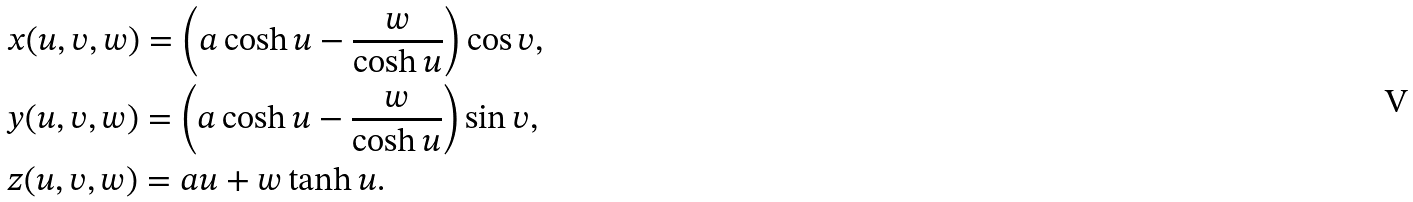Convert formula to latex. <formula><loc_0><loc_0><loc_500><loc_500>& x ( u , v , w ) = \left ( a \cosh u - \frac { w } { \cosh u } \right ) \cos v , \\ & y ( u , v , w ) = \left ( a \cosh u - \frac { w } { \cosh u } \right ) \sin v , \\ & z ( u , v , w ) = a u + w \tanh u .</formula> 